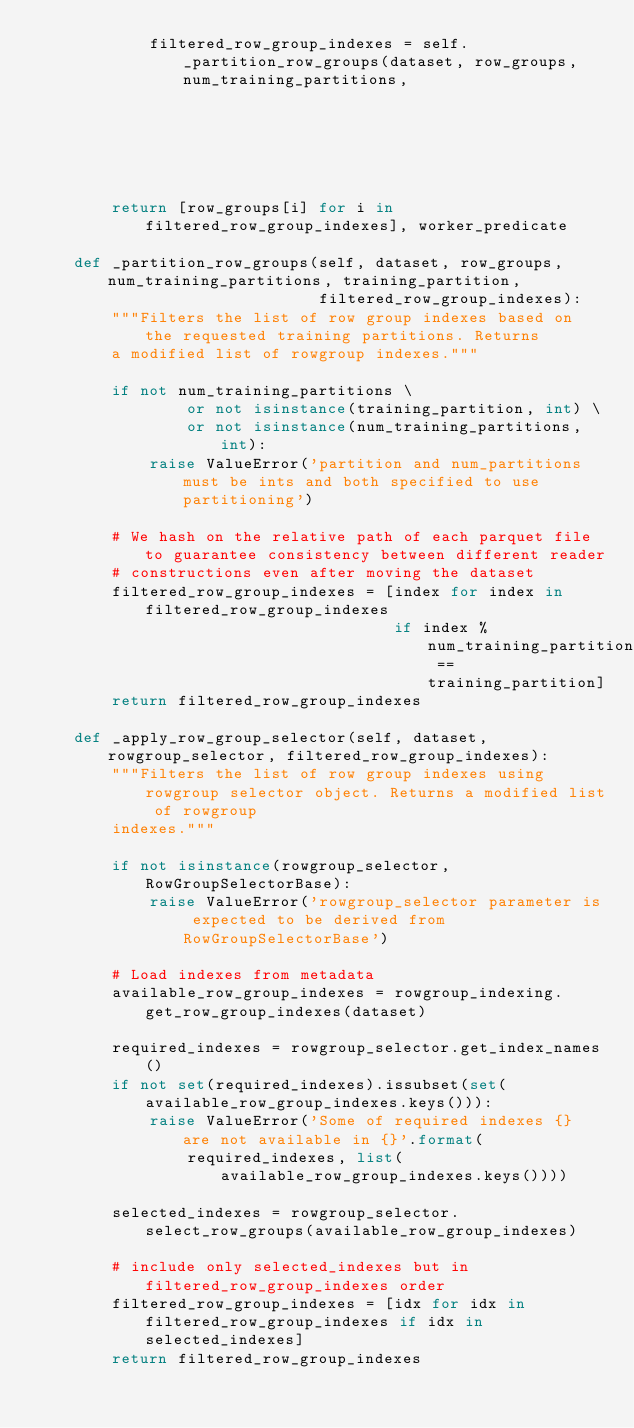<code> <loc_0><loc_0><loc_500><loc_500><_Python_>            filtered_row_group_indexes = self._partition_row_groups(dataset, row_groups, num_training_partitions,
                                                                    training_partition,
                                                                    filtered_row_group_indexes)
        return [row_groups[i] for i in filtered_row_group_indexes], worker_predicate

    def _partition_row_groups(self, dataset, row_groups, num_training_partitions, training_partition,
                              filtered_row_group_indexes):
        """Filters the list of row group indexes based on the requested training partitions. Returns
        a modified list of rowgroup indexes."""

        if not num_training_partitions \
                or not isinstance(training_partition, int) \
                or not isinstance(num_training_partitions, int):
            raise ValueError('partition and num_partitions must be ints and both specified to use partitioning')

        # We hash on the relative path of each parquet file to guarantee consistency between different reader
        # constructions even after moving the dataset
        filtered_row_group_indexes = [index for index in filtered_row_group_indexes
                                      if index % num_training_partitions == training_partition]
        return filtered_row_group_indexes

    def _apply_row_group_selector(self, dataset, rowgroup_selector, filtered_row_group_indexes):
        """Filters the list of row group indexes using rowgroup selector object. Returns a modified list of rowgroup
        indexes."""

        if not isinstance(rowgroup_selector, RowGroupSelectorBase):
            raise ValueError('rowgroup_selector parameter is expected to be derived from RowGroupSelectorBase')

        # Load indexes from metadata
        available_row_group_indexes = rowgroup_indexing.get_row_group_indexes(dataset)

        required_indexes = rowgroup_selector.get_index_names()
        if not set(required_indexes).issubset(set(available_row_group_indexes.keys())):
            raise ValueError('Some of required indexes {} are not available in {}'.format(
                required_indexes, list(available_row_group_indexes.keys())))

        selected_indexes = rowgroup_selector.select_row_groups(available_row_group_indexes)

        # include only selected_indexes but in filtered_row_group_indexes order
        filtered_row_group_indexes = [idx for idx in filtered_row_group_indexes if idx in selected_indexes]
        return filtered_row_group_indexes
</code> 